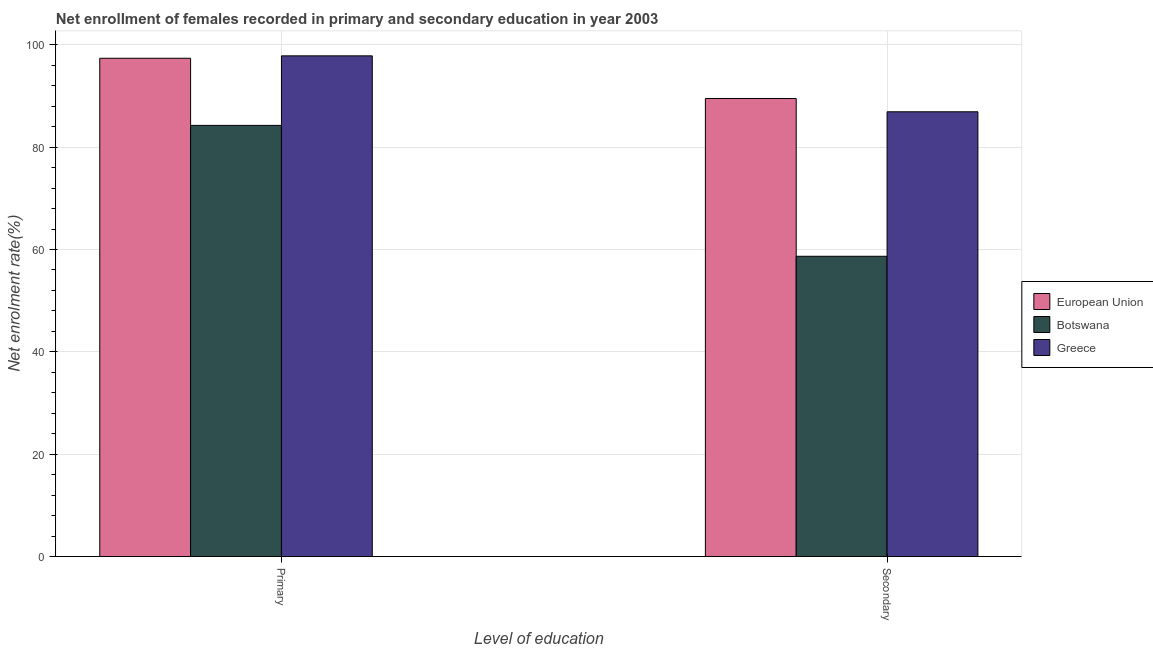Are the number of bars per tick equal to the number of legend labels?
Keep it short and to the point. Yes. How many bars are there on the 2nd tick from the right?
Make the answer very short. 3. What is the label of the 1st group of bars from the left?
Provide a short and direct response. Primary. What is the enrollment rate in primary education in European Union?
Give a very brief answer. 97.37. Across all countries, what is the maximum enrollment rate in secondary education?
Keep it short and to the point. 89.5. Across all countries, what is the minimum enrollment rate in secondary education?
Ensure brevity in your answer.  58.68. In which country was the enrollment rate in primary education minimum?
Keep it short and to the point. Botswana. What is the total enrollment rate in secondary education in the graph?
Make the answer very short. 235.09. What is the difference between the enrollment rate in primary education in Botswana and that in European Union?
Provide a short and direct response. -13.12. What is the difference between the enrollment rate in secondary education in Greece and the enrollment rate in primary education in Botswana?
Offer a very short reply. 2.66. What is the average enrollment rate in secondary education per country?
Offer a terse response. 78.36. What is the difference between the enrollment rate in primary education and enrollment rate in secondary education in Greece?
Offer a very short reply. 10.93. What is the ratio of the enrollment rate in primary education in European Union to that in Greece?
Provide a short and direct response. 1. Is the enrollment rate in secondary education in Botswana less than that in European Union?
Make the answer very short. Yes. What does the 3rd bar from the left in Primary represents?
Your response must be concise. Greece. What does the 2nd bar from the right in Secondary represents?
Give a very brief answer. Botswana. How many bars are there?
Provide a short and direct response. 6. Are all the bars in the graph horizontal?
Give a very brief answer. No. How many countries are there in the graph?
Ensure brevity in your answer.  3. What is the difference between two consecutive major ticks on the Y-axis?
Give a very brief answer. 20. Are the values on the major ticks of Y-axis written in scientific E-notation?
Ensure brevity in your answer.  No. Does the graph contain any zero values?
Your answer should be compact. No. Does the graph contain grids?
Your response must be concise. Yes. Where does the legend appear in the graph?
Give a very brief answer. Center right. How are the legend labels stacked?
Your response must be concise. Vertical. What is the title of the graph?
Provide a succinct answer. Net enrollment of females recorded in primary and secondary education in year 2003. Does "Georgia" appear as one of the legend labels in the graph?
Ensure brevity in your answer.  No. What is the label or title of the X-axis?
Keep it short and to the point. Level of education. What is the label or title of the Y-axis?
Your response must be concise. Net enrolment rate(%). What is the Net enrolment rate(%) of European Union in Primary?
Offer a very short reply. 97.37. What is the Net enrolment rate(%) in Botswana in Primary?
Your answer should be very brief. 84.26. What is the Net enrolment rate(%) of Greece in Primary?
Make the answer very short. 97.84. What is the Net enrolment rate(%) in European Union in Secondary?
Make the answer very short. 89.5. What is the Net enrolment rate(%) in Botswana in Secondary?
Ensure brevity in your answer.  58.68. What is the Net enrolment rate(%) of Greece in Secondary?
Give a very brief answer. 86.91. Across all Level of education, what is the maximum Net enrolment rate(%) of European Union?
Provide a short and direct response. 97.37. Across all Level of education, what is the maximum Net enrolment rate(%) of Botswana?
Give a very brief answer. 84.26. Across all Level of education, what is the maximum Net enrolment rate(%) of Greece?
Give a very brief answer. 97.84. Across all Level of education, what is the minimum Net enrolment rate(%) of European Union?
Keep it short and to the point. 89.5. Across all Level of education, what is the minimum Net enrolment rate(%) in Botswana?
Your answer should be compact. 58.68. Across all Level of education, what is the minimum Net enrolment rate(%) in Greece?
Make the answer very short. 86.91. What is the total Net enrolment rate(%) in European Union in the graph?
Provide a succinct answer. 186.87. What is the total Net enrolment rate(%) of Botswana in the graph?
Make the answer very short. 142.93. What is the total Net enrolment rate(%) in Greece in the graph?
Ensure brevity in your answer.  184.75. What is the difference between the Net enrolment rate(%) of European Union in Primary and that in Secondary?
Your answer should be very brief. 7.87. What is the difference between the Net enrolment rate(%) in Botswana in Primary and that in Secondary?
Provide a succinct answer. 25.58. What is the difference between the Net enrolment rate(%) in Greece in Primary and that in Secondary?
Your answer should be very brief. 10.93. What is the difference between the Net enrolment rate(%) of European Union in Primary and the Net enrolment rate(%) of Botswana in Secondary?
Provide a short and direct response. 38.7. What is the difference between the Net enrolment rate(%) in European Union in Primary and the Net enrolment rate(%) in Greece in Secondary?
Your answer should be very brief. 10.46. What is the difference between the Net enrolment rate(%) of Botswana in Primary and the Net enrolment rate(%) of Greece in Secondary?
Give a very brief answer. -2.66. What is the average Net enrolment rate(%) of European Union per Level of education?
Your answer should be very brief. 93.44. What is the average Net enrolment rate(%) in Botswana per Level of education?
Give a very brief answer. 71.47. What is the average Net enrolment rate(%) in Greece per Level of education?
Make the answer very short. 92.38. What is the difference between the Net enrolment rate(%) in European Union and Net enrolment rate(%) in Botswana in Primary?
Give a very brief answer. 13.12. What is the difference between the Net enrolment rate(%) in European Union and Net enrolment rate(%) in Greece in Primary?
Ensure brevity in your answer.  -0.47. What is the difference between the Net enrolment rate(%) of Botswana and Net enrolment rate(%) of Greece in Primary?
Offer a terse response. -13.59. What is the difference between the Net enrolment rate(%) of European Union and Net enrolment rate(%) of Botswana in Secondary?
Your response must be concise. 30.83. What is the difference between the Net enrolment rate(%) in European Union and Net enrolment rate(%) in Greece in Secondary?
Your response must be concise. 2.59. What is the difference between the Net enrolment rate(%) of Botswana and Net enrolment rate(%) of Greece in Secondary?
Offer a terse response. -28.24. What is the ratio of the Net enrolment rate(%) of European Union in Primary to that in Secondary?
Keep it short and to the point. 1.09. What is the ratio of the Net enrolment rate(%) in Botswana in Primary to that in Secondary?
Your answer should be compact. 1.44. What is the ratio of the Net enrolment rate(%) in Greece in Primary to that in Secondary?
Give a very brief answer. 1.13. What is the difference between the highest and the second highest Net enrolment rate(%) of European Union?
Your response must be concise. 7.87. What is the difference between the highest and the second highest Net enrolment rate(%) in Botswana?
Make the answer very short. 25.58. What is the difference between the highest and the second highest Net enrolment rate(%) of Greece?
Ensure brevity in your answer.  10.93. What is the difference between the highest and the lowest Net enrolment rate(%) in European Union?
Provide a short and direct response. 7.87. What is the difference between the highest and the lowest Net enrolment rate(%) in Botswana?
Your answer should be very brief. 25.58. What is the difference between the highest and the lowest Net enrolment rate(%) in Greece?
Offer a terse response. 10.93. 